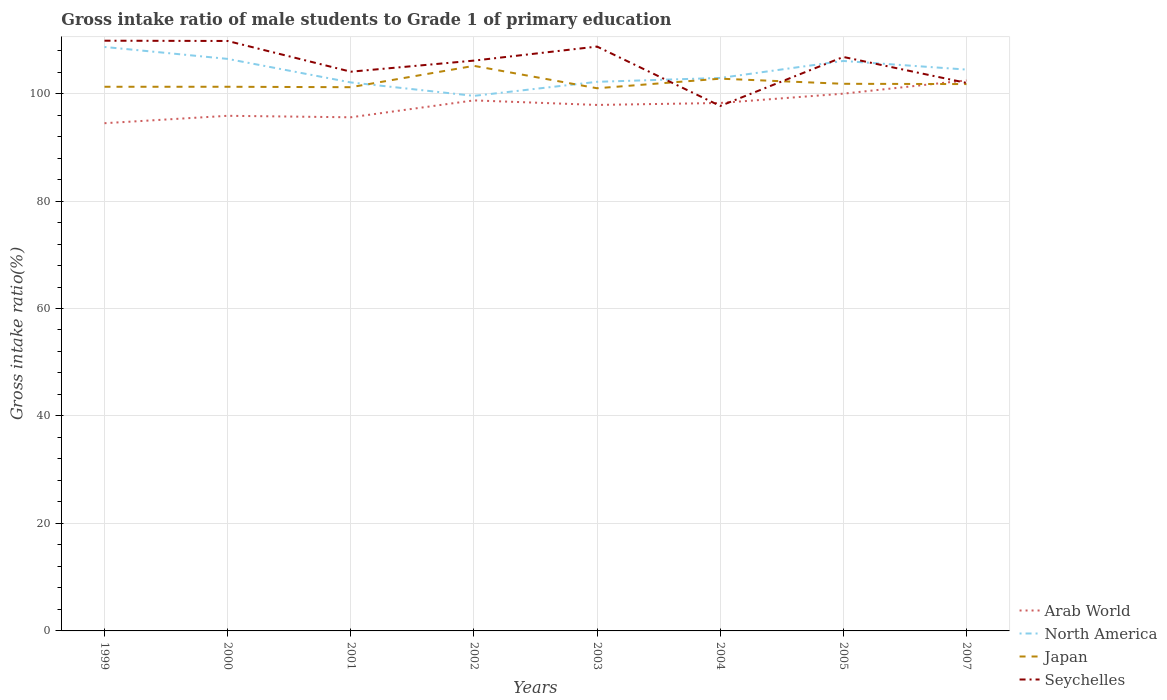How many different coloured lines are there?
Your answer should be very brief. 4. Does the line corresponding to North America intersect with the line corresponding to Seychelles?
Your answer should be very brief. Yes. Across all years, what is the maximum gross intake ratio in Arab World?
Your answer should be very brief. 94.48. What is the total gross intake ratio in Seychelles in the graph?
Keep it short and to the point. 1.04. What is the difference between the highest and the second highest gross intake ratio in Arab World?
Your answer should be very brief. 7.97. What is the difference between the highest and the lowest gross intake ratio in Japan?
Your response must be concise. 2. Is the gross intake ratio in Seychelles strictly greater than the gross intake ratio in Arab World over the years?
Ensure brevity in your answer.  No. How many years are there in the graph?
Give a very brief answer. 8. Are the values on the major ticks of Y-axis written in scientific E-notation?
Make the answer very short. No. Does the graph contain any zero values?
Give a very brief answer. No. Where does the legend appear in the graph?
Give a very brief answer. Bottom right. What is the title of the graph?
Your answer should be compact. Gross intake ratio of male students to Grade 1 of primary education. Does "Guinea" appear as one of the legend labels in the graph?
Ensure brevity in your answer.  No. What is the label or title of the Y-axis?
Provide a succinct answer. Gross intake ratio(%). What is the Gross intake ratio(%) of Arab World in 1999?
Your answer should be compact. 94.48. What is the Gross intake ratio(%) of North America in 1999?
Offer a terse response. 108.67. What is the Gross intake ratio(%) in Japan in 1999?
Keep it short and to the point. 101.26. What is the Gross intake ratio(%) of Seychelles in 1999?
Ensure brevity in your answer.  109.84. What is the Gross intake ratio(%) of Arab World in 2000?
Give a very brief answer. 95.86. What is the Gross intake ratio(%) in North America in 2000?
Your answer should be very brief. 106.45. What is the Gross intake ratio(%) in Japan in 2000?
Ensure brevity in your answer.  101.26. What is the Gross intake ratio(%) of Seychelles in 2000?
Make the answer very short. 109.78. What is the Gross intake ratio(%) of Arab World in 2001?
Provide a short and direct response. 95.58. What is the Gross intake ratio(%) in North America in 2001?
Your response must be concise. 102.07. What is the Gross intake ratio(%) of Japan in 2001?
Ensure brevity in your answer.  101.18. What is the Gross intake ratio(%) of Seychelles in 2001?
Your answer should be compact. 104.07. What is the Gross intake ratio(%) in Arab World in 2002?
Your response must be concise. 98.73. What is the Gross intake ratio(%) of North America in 2002?
Your answer should be compact. 99.57. What is the Gross intake ratio(%) of Japan in 2002?
Give a very brief answer. 105.16. What is the Gross intake ratio(%) in Seychelles in 2002?
Make the answer very short. 106.13. What is the Gross intake ratio(%) of Arab World in 2003?
Keep it short and to the point. 97.88. What is the Gross intake ratio(%) in North America in 2003?
Offer a terse response. 102.18. What is the Gross intake ratio(%) of Japan in 2003?
Ensure brevity in your answer.  100.99. What is the Gross intake ratio(%) in Seychelles in 2003?
Ensure brevity in your answer.  108.74. What is the Gross intake ratio(%) in Arab World in 2004?
Ensure brevity in your answer.  98.24. What is the Gross intake ratio(%) of North America in 2004?
Provide a succinct answer. 102.9. What is the Gross intake ratio(%) in Japan in 2004?
Provide a short and direct response. 102.77. What is the Gross intake ratio(%) in Seychelles in 2004?
Keep it short and to the point. 97.69. What is the Gross intake ratio(%) in Arab World in 2005?
Your answer should be very brief. 99.98. What is the Gross intake ratio(%) in North America in 2005?
Ensure brevity in your answer.  106.07. What is the Gross intake ratio(%) in Japan in 2005?
Provide a succinct answer. 101.82. What is the Gross intake ratio(%) of Seychelles in 2005?
Give a very brief answer. 106.81. What is the Gross intake ratio(%) in Arab World in 2007?
Provide a succinct answer. 102.45. What is the Gross intake ratio(%) of North America in 2007?
Make the answer very short. 104.46. What is the Gross intake ratio(%) of Japan in 2007?
Give a very brief answer. 101.76. What is the Gross intake ratio(%) of Seychelles in 2007?
Keep it short and to the point. 101.98. Across all years, what is the maximum Gross intake ratio(%) in Arab World?
Keep it short and to the point. 102.45. Across all years, what is the maximum Gross intake ratio(%) in North America?
Make the answer very short. 108.67. Across all years, what is the maximum Gross intake ratio(%) in Japan?
Offer a terse response. 105.16. Across all years, what is the maximum Gross intake ratio(%) in Seychelles?
Provide a succinct answer. 109.84. Across all years, what is the minimum Gross intake ratio(%) of Arab World?
Ensure brevity in your answer.  94.48. Across all years, what is the minimum Gross intake ratio(%) of North America?
Your response must be concise. 99.57. Across all years, what is the minimum Gross intake ratio(%) of Japan?
Your response must be concise. 100.99. Across all years, what is the minimum Gross intake ratio(%) in Seychelles?
Your answer should be compact. 97.69. What is the total Gross intake ratio(%) in Arab World in the graph?
Ensure brevity in your answer.  783.21. What is the total Gross intake ratio(%) of North America in the graph?
Give a very brief answer. 832.38. What is the total Gross intake ratio(%) of Japan in the graph?
Make the answer very short. 816.21. What is the total Gross intake ratio(%) in Seychelles in the graph?
Offer a very short reply. 845.05. What is the difference between the Gross intake ratio(%) of Arab World in 1999 and that in 2000?
Keep it short and to the point. -1.38. What is the difference between the Gross intake ratio(%) in North America in 1999 and that in 2000?
Make the answer very short. 2.22. What is the difference between the Gross intake ratio(%) in Japan in 1999 and that in 2000?
Ensure brevity in your answer.  0. What is the difference between the Gross intake ratio(%) of Seychelles in 1999 and that in 2000?
Make the answer very short. 0.05. What is the difference between the Gross intake ratio(%) in North America in 1999 and that in 2001?
Make the answer very short. 6.6. What is the difference between the Gross intake ratio(%) in Japan in 1999 and that in 2001?
Your response must be concise. 0.08. What is the difference between the Gross intake ratio(%) of Seychelles in 1999 and that in 2001?
Keep it short and to the point. 5.77. What is the difference between the Gross intake ratio(%) of Arab World in 1999 and that in 2002?
Make the answer very short. -4.25. What is the difference between the Gross intake ratio(%) in North America in 1999 and that in 2002?
Provide a short and direct response. 9.1. What is the difference between the Gross intake ratio(%) of Japan in 1999 and that in 2002?
Your answer should be very brief. -3.89. What is the difference between the Gross intake ratio(%) of Seychelles in 1999 and that in 2002?
Provide a succinct answer. 3.71. What is the difference between the Gross intake ratio(%) of North America in 1999 and that in 2003?
Your answer should be very brief. 6.49. What is the difference between the Gross intake ratio(%) of Japan in 1999 and that in 2003?
Your answer should be very brief. 0.28. What is the difference between the Gross intake ratio(%) of Seychelles in 1999 and that in 2003?
Make the answer very short. 1.09. What is the difference between the Gross intake ratio(%) of Arab World in 1999 and that in 2004?
Keep it short and to the point. -3.76. What is the difference between the Gross intake ratio(%) of North America in 1999 and that in 2004?
Offer a very short reply. 5.77. What is the difference between the Gross intake ratio(%) of Japan in 1999 and that in 2004?
Offer a very short reply. -1.5. What is the difference between the Gross intake ratio(%) in Seychelles in 1999 and that in 2004?
Your answer should be compact. 12.14. What is the difference between the Gross intake ratio(%) of Arab World in 1999 and that in 2005?
Ensure brevity in your answer.  -5.5. What is the difference between the Gross intake ratio(%) in North America in 1999 and that in 2005?
Your answer should be compact. 2.61. What is the difference between the Gross intake ratio(%) of Japan in 1999 and that in 2005?
Offer a terse response. -0.55. What is the difference between the Gross intake ratio(%) of Seychelles in 1999 and that in 2005?
Give a very brief answer. 3.02. What is the difference between the Gross intake ratio(%) of Arab World in 1999 and that in 2007?
Offer a terse response. -7.97. What is the difference between the Gross intake ratio(%) of North America in 1999 and that in 2007?
Offer a very short reply. 4.21. What is the difference between the Gross intake ratio(%) in Japan in 1999 and that in 2007?
Offer a terse response. -0.5. What is the difference between the Gross intake ratio(%) in Seychelles in 1999 and that in 2007?
Give a very brief answer. 7.85. What is the difference between the Gross intake ratio(%) of Arab World in 2000 and that in 2001?
Offer a terse response. 0.28. What is the difference between the Gross intake ratio(%) in North America in 2000 and that in 2001?
Provide a succinct answer. 4.38. What is the difference between the Gross intake ratio(%) in Japan in 2000 and that in 2001?
Keep it short and to the point. 0.08. What is the difference between the Gross intake ratio(%) of Seychelles in 2000 and that in 2001?
Keep it short and to the point. 5.72. What is the difference between the Gross intake ratio(%) of Arab World in 2000 and that in 2002?
Your answer should be compact. -2.87. What is the difference between the Gross intake ratio(%) in North America in 2000 and that in 2002?
Your answer should be very brief. 6.88. What is the difference between the Gross intake ratio(%) of Japan in 2000 and that in 2002?
Keep it short and to the point. -3.89. What is the difference between the Gross intake ratio(%) of Seychelles in 2000 and that in 2002?
Ensure brevity in your answer.  3.65. What is the difference between the Gross intake ratio(%) in Arab World in 2000 and that in 2003?
Ensure brevity in your answer.  -2.02. What is the difference between the Gross intake ratio(%) of North America in 2000 and that in 2003?
Provide a short and direct response. 4.27. What is the difference between the Gross intake ratio(%) in Japan in 2000 and that in 2003?
Your answer should be compact. 0.28. What is the difference between the Gross intake ratio(%) in Seychelles in 2000 and that in 2003?
Provide a succinct answer. 1.04. What is the difference between the Gross intake ratio(%) in Arab World in 2000 and that in 2004?
Keep it short and to the point. -2.38. What is the difference between the Gross intake ratio(%) in North America in 2000 and that in 2004?
Provide a succinct answer. 3.55. What is the difference between the Gross intake ratio(%) in Japan in 2000 and that in 2004?
Provide a short and direct response. -1.5. What is the difference between the Gross intake ratio(%) in Seychelles in 2000 and that in 2004?
Ensure brevity in your answer.  12.09. What is the difference between the Gross intake ratio(%) in Arab World in 2000 and that in 2005?
Offer a very short reply. -4.12. What is the difference between the Gross intake ratio(%) in North America in 2000 and that in 2005?
Offer a very short reply. 0.38. What is the difference between the Gross intake ratio(%) in Japan in 2000 and that in 2005?
Offer a very short reply. -0.55. What is the difference between the Gross intake ratio(%) in Seychelles in 2000 and that in 2005?
Provide a succinct answer. 2.97. What is the difference between the Gross intake ratio(%) in Arab World in 2000 and that in 2007?
Give a very brief answer. -6.59. What is the difference between the Gross intake ratio(%) of North America in 2000 and that in 2007?
Keep it short and to the point. 1.99. What is the difference between the Gross intake ratio(%) in Japan in 2000 and that in 2007?
Provide a succinct answer. -0.5. What is the difference between the Gross intake ratio(%) of Seychelles in 2000 and that in 2007?
Give a very brief answer. 7.8. What is the difference between the Gross intake ratio(%) in Arab World in 2001 and that in 2002?
Offer a terse response. -3.15. What is the difference between the Gross intake ratio(%) in North America in 2001 and that in 2002?
Offer a very short reply. 2.5. What is the difference between the Gross intake ratio(%) in Japan in 2001 and that in 2002?
Offer a terse response. -3.97. What is the difference between the Gross intake ratio(%) in Seychelles in 2001 and that in 2002?
Your answer should be compact. -2.06. What is the difference between the Gross intake ratio(%) of North America in 2001 and that in 2003?
Provide a succinct answer. -0.11. What is the difference between the Gross intake ratio(%) in Japan in 2001 and that in 2003?
Ensure brevity in your answer.  0.2. What is the difference between the Gross intake ratio(%) of Seychelles in 2001 and that in 2003?
Make the answer very short. -4.68. What is the difference between the Gross intake ratio(%) of Arab World in 2001 and that in 2004?
Your answer should be very brief. -2.66. What is the difference between the Gross intake ratio(%) in North America in 2001 and that in 2004?
Make the answer very short. -0.83. What is the difference between the Gross intake ratio(%) in Japan in 2001 and that in 2004?
Provide a short and direct response. -1.58. What is the difference between the Gross intake ratio(%) of Seychelles in 2001 and that in 2004?
Your answer should be very brief. 6.38. What is the difference between the Gross intake ratio(%) in Arab World in 2001 and that in 2005?
Keep it short and to the point. -4.4. What is the difference between the Gross intake ratio(%) of North America in 2001 and that in 2005?
Ensure brevity in your answer.  -3.99. What is the difference between the Gross intake ratio(%) in Japan in 2001 and that in 2005?
Offer a terse response. -0.63. What is the difference between the Gross intake ratio(%) of Seychelles in 2001 and that in 2005?
Give a very brief answer. -2.74. What is the difference between the Gross intake ratio(%) in Arab World in 2001 and that in 2007?
Your answer should be very brief. -6.87. What is the difference between the Gross intake ratio(%) in North America in 2001 and that in 2007?
Keep it short and to the point. -2.39. What is the difference between the Gross intake ratio(%) of Japan in 2001 and that in 2007?
Provide a short and direct response. -0.58. What is the difference between the Gross intake ratio(%) of Seychelles in 2001 and that in 2007?
Provide a succinct answer. 2.09. What is the difference between the Gross intake ratio(%) in Arab World in 2002 and that in 2003?
Make the answer very short. 0.84. What is the difference between the Gross intake ratio(%) in North America in 2002 and that in 2003?
Your response must be concise. -2.61. What is the difference between the Gross intake ratio(%) in Japan in 2002 and that in 2003?
Your answer should be very brief. 4.17. What is the difference between the Gross intake ratio(%) in Seychelles in 2002 and that in 2003?
Provide a succinct answer. -2.61. What is the difference between the Gross intake ratio(%) of Arab World in 2002 and that in 2004?
Provide a succinct answer. 0.48. What is the difference between the Gross intake ratio(%) of North America in 2002 and that in 2004?
Ensure brevity in your answer.  -3.33. What is the difference between the Gross intake ratio(%) of Japan in 2002 and that in 2004?
Your answer should be very brief. 2.39. What is the difference between the Gross intake ratio(%) of Seychelles in 2002 and that in 2004?
Offer a terse response. 8.44. What is the difference between the Gross intake ratio(%) of Arab World in 2002 and that in 2005?
Your answer should be compact. -1.25. What is the difference between the Gross intake ratio(%) of North America in 2002 and that in 2005?
Provide a succinct answer. -6.49. What is the difference between the Gross intake ratio(%) in Japan in 2002 and that in 2005?
Your response must be concise. 3.34. What is the difference between the Gross intake ratio(%) of Seychelles in 2002 and that in 2005?
Your answer should be compact. -0.68. What is the difference between the Gross intake ratio(%) in Arab World in 2002 and that in 2007?
Provide a succinct answer. -3.72. What is the difference between the Gross intake ratio(%) of North America in 2002 and that in 2007?
Ensure brevity in your answer.  -4.89. What is the difference between the Gross intake ratio(%) in Japan in 2002 and that in 2007?
Your answer should be very brief. 3.39. What is the difference between the Gross intake ratio(%) of Seychelles in 2002 and that in 2007?
Keep it short and to the point. 4.15. What is the difference between the Gross intake ratio(%) of Arab World in 2003 and that in 2004?
Provide a succinct answer. -0.36. What is the difference between the Gross intake ratio(%) of North America in 2003 and that in 2004?
Your answer should be very brief. -0.72. What is the difference between the Gross intake ratio(%) in Japan in 2003 and that in 2004?
Your answer should be compact. -1.78. What is the difference between the Gross intake ratio(%) of Seychelles in 2003 and that in 2004?
Offer a terse response. 11.05. What is the difference between the Gross intake ratio(%) in Arab World in 2003 and that in 2005?
Offer a very short reply. -2.1. What is the difference between the Gross intake ratio(%) in North America in 2003 and that in 2005?
Give a very brief answer. -3.88. What is the difference between the Gross intake ratio(%) of Japan in 2003 and that in 2005?
Your response must be concise. -0.83. What is the difference between the Gross intake ratio(%) of Seychelles in 2003 and that in 2005?
Your answer should be very brief. 1.93. What is the difference between the Gross intake ratio(%) in Arab World in 2003 and that in 2007?
Your answer should be compact. -4.57. What is the difference between the Gross intake ratio(%) in North America in 2003 and that in 2007?
Offer a terse response. -2.28. What is the difference between the Gross intake ratio(%) in Japan in 2003 and that in 2007?
Offer a terse response. -0.78. What is the difference between the Gross intake ratio(%) in Seychelles in 2003 and that in 2007?
Give a very brief answer. 6.76. What is the difference between the Gross intake ratio(%) of Arab World in 2004 and that in 2005?
Offer a very short reply. -1.73. What is the difference between the Gross intake ratio(%) in North America in 2004 and that in 2005?
Offer a very short reply. -3.16. What is the difference between the Gross intake ratio(%) of Japan in 2004 and that in 2005?
Offer a terse response. 0.95. What is the difference between the Gross intake ratio(%) of Seychelles in 2004 and that in 2005?
Keep it short and to the point. -9.12. What is the difference between the Gross intake ratio(%) of Arab World in 2004 and that in 2007?
Make the answer very short. -4.2. What is the difference between the Gross intake ratio(%) of North America in 2004 and that in 2007?
Provide a short and direct response. -1.56. What is the difference between the Gross intake ratio(%) of Japan in 2004 and that in 2007?
Offer a terse response. 1. What is the difference between the Gross intake ratio(%) in Seychelles in 2004 and that in 2007?
Offer a very short reply. -4.29. What is the difference between the Gross intake ratio(%) in Arab World in 2005 and that in 2007?
Your response must be concise. -2.47. What is the difference between the Gross intake ratio(%) in North America in 2005 and that in 2007?
Offer a terse response. 1.6. What is the difference between the Gross intake ratio(%) of Japan in 2005 and that in 2007?
Offer a very short reply. 0.05. What is the difference between the Gross intake ratio(%) in Seychelles in 2005 and that in 2007?
Keep it short and to the point. 4.83. What is the difference between the Gross intake ratio(%) of Arab World in 1999 and the Gross intake ratio(%) of North America in 2000?
Offer a very short reply. -11.97. What is the difference between the Gross intake ratio(%) of Arab World in 1999 and the Gross intake ratio(%) of Japan in 2000?
Make the answer very short. -6.78. What is the difference between the Gross intake ratio(%) in Arab World in 1999 and the Gross intake ratio(%) in Seychelles in 2000?
Your answer should be compact. -15.3. What is the difference between the Gross intake ratio(%) in North America in 1999 and the Gross intake ratio(%) in Japan in 2000?
Ensure brevity in your answer.  7.41. What is the difference between the Gross intake ratio(%) in North America in 1999 and the Gross intake ratio(%) in Seychelles in 2000?
Provide a short and direct response. -1.11. What is the difference between the Gross intake ratio(%) of Japan in 1999 and the Gross intake ratio(%) of Seychelles in 2000?
Ensure brevity in your answer.  -8.52. What is the difference between the Gross intake ratio(%) of Arab World in 1999 and the Gross intake ratio(%) of North America in 2001?
Ensure brevity in your answer.  -7.59. What is the difference between the Gross intake ratio(%) of Arab World in 1999 and the Gross intake ratio(%) of Japan in 2001?
Offer a terse response. -6.7. What is the difference between the Gross intake ratio(%) in Arab World in 1999 and the Gross intake ratio(%) in Seychelles in 2001?
Your answer should be very brief. -9.59. What is the difference between the Gross intake ratio(%) of North America in 1999 and the Gross intake ratio(%) of Japan in 2001?
Provide a succinct answer. 7.49. What is the difference between the Gross intake ratio(%) in North America in 1999 and the Gross intake ratio(%) in Seychelles in 2001?
Keep it short and to the point. 4.6. What is the difference between the Gross intake ratio(%) in Japan in 1999 and the Gross intake ratio(%) in Seychelles in 2001?
Your response must be concise. -2.8. What is the difference between the Gross intake ratio(%) of Arab World in 1999 and the Gross intake ratio(%) of North America in 2002?
Your response must be concise. -5.09. What is the difference between the Gross intake ratio(%) in Arab World in 1999 and the Gross intake ratio(%) in Japan in 2002?
Offer a very short reply. -10.67. What is the difference between the Gross intake ratio(%) of Arab World in 1999 and the Gross intake ratio(%) of Seychelles in 2002?
Offer a very short reply. -11.65. What is the difference between the Gross intake ratio(%) in North America in 1999 and the Gross intake ratio(%) in Japan in 2002?
Offer a terse response. 3.52. What is the difference between the Gross intake ratio(%) in North America in 1999 and the Gross intake ratio(%) in Seychelles in 2002?
Ensure brevity in your answer.  2.54. What is the difference between the Gross intake ratio(%) in Japan in 1999 and the Gross intake ratio(%) in Seychelles in 2002?
Provide a succinct answer. -4.87. What is the difference between the Gross intake ratio(%) in Arab World in 1999 and the Gross intake ratio(%) in North America in 2003?
Your response must be concise. -7.7. What is the difference between the Gross intake ratio(%) of Arab World in 1999 and the Gross intake ratio(%) of Japan in 2003?
Offer a very short reply. -6.5. What is the difference between the Gross intake ratio(%) in Arab World in 1999 and the Gross intake ratio(%) in Seychelles in 2003?
Ensure brevity in your answer.  -14.26. What is the difference between the Gross intake ratio(%) of North America in 1999 and the Gross intake ratio(%) of Japan in 2003?
Keep it short and to the point. 7.68. What is the difference between the Gross intake ratio(%) of North America in 1999 and the Gross intake ratio(%) of Seychelles in 2003?
Offer a very short reply. -0.07. What is the difference between the Gross intake ratio(%) of Japan in 1999 and the Gross intake ratio(%) of Seychelles in 2003?
Provide a succinct answer. -7.48. What is the difference between the Gross intake ratio(%) of Arab World in 1999 and the Gross intake ratio(%) of North America in 2004?
Offer a very short reply. -8.42. What is the difference between the Gross intake ratio(%) in Arab World in 1999 and the Gross intake ratio(%) in Japan in 2004?
Make the answer very short. -8.29. What is the difference between the Gross intake ratio(%) in Arab World in 1999 and the Gross intake ratio(%) in Seychelles in 2004?
Provide a short and direct response. -3.21. What is the difference between the Gross intake ratio(%) of North America in 1999 and the Gross intake ratio(%) of Japan in 2004?
Offer a very short reply. 5.9. What is the difference between the Gross intake ratio(%) of North America in 1999 and the Gross intake ratio(%) of Seychelles in 2004?
Your answer should be very brief. 10.98. What is the difference between the Gross intake ratio(%) of Japan in 1999 and the Gross intake ratio(%) of Seychelles in 2004?
Offer a very short reply. 3.57. What is the difference between the Gross intake ratio(%) of Arab World in 1999 and the Gross intake ratio(%) of North America in 2005?
Provide a short and direct response. -11.58. What is the difference between the Gross intake ratio(%) in Arab World in 1999 and the Gross intake ratio(%) in Japan in 2005?
Keep it short and to the point. -7.33. What is the difference between the Gross intake ratio(%) of Arab World in 1999 and the Gross intake ratio(%) of Seychelles in 2005?
Make the answer very short. -12.33. What is the difference between the Gross intake ratio(%) in North America in 1999 and the Gross intake ratio(%) in Japan in 2005?
Keep it short and to the point. 6.86. What is the difference between the Gross intake ratio(%) of North America in 1999 and the Gross intake ratio(%) of Seychelles in 2005?
Make the answer very short. 1.86. What is the difference between the Gross intake ratio(%) in Japan in 1999 and the Gross intake ratio(%) in Seychelles in 2005?
Your response must be concise. -5.55. What is the difference between the Gross intake ratio(%) of Arab World in 1999 and the Gross intake ratio(%) of North America in 2007?
Ensure brevity in your answer.  -9.98. What is the difference between the Gross intake ratio(%) in Arab World in 1999 and the Gross intake ratio(%) in Japan in 2007?
Offer a very short reply. -7.28. What is the difference between the Gross intake ratio(%) in Arab World in 1999 and the Gross intake ratio(%) in Seychelles in 2007?
Your answer should be very brief. -7.5. What is the difference between the Gross intake ratio(%) of North America in 1999 and the Gross intake ratio(%) of Japan in 2007?
Provide a succinct answer. 6.91. What is the difference between the Gross intake ratio(%) of North America in 1999 and the Gross intake ratio(%) of Seychelles in 2007?
Make the answer very short. 6.69. What is the difference between the Gross intake ratio(%) in Japan in 1999 and the Gross intake ratio(%) in Seychelles in 2007?
Provide a succinct answer. -0.72. What is the difference between the Gross intake ratio(%) in Arab World in 2000 and the Gross intake ratio(%) in North America in 2001?
Make the answer very short. -6.21. What is the difference between the Gross intake ratio(%) in Arab World in 2000 and the Gross intake ratio(%) in Japan in 2001?
Make the answer very short. -5.32. What is the difference between the Gross intake ratio(%) of Arab World in 2000 and the Gross intake ratio(%) of Seychelles in 2001?
Offer a terse response. -8.21. What is the difference between the Gross intake ratio(%) of North America in 2000 and the Gross intake ratio(%) of Japan in 2001?
Make the answer very short. 5.27. What is the difference between the Gross intake ratio(%) of North America in 2000 and the Gross intake ratio(%) of Seychelles in 2001?
Make the answer very short. 2.38. What is the difference between the Gross intake ratio(%) of Japan in 2000 and the Gross intake ratio(%) of Seychelles in 2001?
Your answer should be very brief. -2.8. What is the difference between the Gross intake ratio(%) of Arab World in 2000 and the Gross intake ratio(%) of North America in 2002?
Your answer should be compact. -3.71. What is the difference between the Gross intake ratio(%) of Arab World in 2000 and the Gross intake ratio(%) of Japan in 2002?
Make the answer very short. -9.3. What is the difference between the Gross intake ratio(%) in Arab World in 2000 and the Gross intake ratio(%) in Seychelles in 2002?
Your answer should be compact. -10.27. What is the difference between the Gross intake ratio(%) of North America in 2000 and the Gross intake ratio(%) of Japan in 2002?
Provide a succinct answer. 1.29. What is the difference between the Gross intake ratio(%) in North America in 2000 and the Gross intake ratio(%) in Seychelles in 2002?
Your response must be concise. 0.32. What is the difference between the Gross intake ratio(%) of Japan in 2000 and the Gross intake ratio(%) of Seychelles in 2002?
Your answer should be compact. -4.87. What is the difference between the Gross intake ratio(%) in Arab World in 2000 and the Gross intake ratio(%) in North America in 2003?
Give a very brief answer. -6.32. What is the difference between the Gross intake ratio(%) of Arab World in 2000 and the Gross intake ratio(%) of Japan in 2003?
Give a very brief answer. -5.13. What is the difference between the Gross intake ratio(%) in Arab World in 2000 and the Gross intake ratio(%) in Seychelles in 2003?
Your answer should be very brief. -12.88. What is the difference between the Gross intake ratio(%) of North America in 2000 and the Gross intake ratio(%) of Japan in 2003?
Your answer should be compact. 5.46. What is the difference between the Gross intake ratio(%) of North America in 2000 and the Gross intake ratio(%) of Seychelles in 2003?
Keep it short and to the point. -2.29. What is the difference between the Gross intake ratio(%) in Japan in 2000 and the Gross intake ratio(%) in Seychelles in 2003?
Ensure brevity in your answer.  -7.48. What is the difference between the Gross intake ratio(%) in Arab World in 2000 and the Gross intake ratio(%) in North America in 2004?
Your response must be concise. -7.04. What is the difference between the Gross intake ratio(%) in Arab World in 2000 and the Gross intake ratio(%) in Japan in 2004?
Your response must be concise. -6.91. What is the difference between the Gross intake ratio(%) in Arab World in 2000 and the Gross intake ratio(%) in Seychelles in 2004?
Your answer should be very brief. -1.83. What is the difference between the Gross intake ratio(%) in North America in 2000 and the Gross intake ratio(%) in Japan in 2004?
Your answer should be compact. 3.68. What is the difference between the Gross intake ratio(%) in North America in 2000 and the Gross intake ratio(%) in Seychelles in 2004?
Make the answer very short. 8.76. What is the difference between the Gross intake ratio(%) in Japan in 2000 and the Gross intake ratio(%) in Seychelles in 2004?
Give a very brief answer. 3.57. What is the difference between the Gross intake ratio(%) of Arab World in 2000 and the Gross intake ratio(%) of North America in 2005?
Provide a succinct answer. -10.2. What is the difference between the Gross intake ratio(%) in Arab World in 2000 and the Gross intake ratio(%) in Japan in 2005?
Provide a short and direct response. -5.95. What is the difference between the Gross intake ratio(%) of Arab World in 2000 and the Gross intake ratio(%) of Seychelles in 2005?
Give a very brief answer. -10.95. What is the difference between the Gross intake ratio(%) in North America in 2000 and the Gross intake ratio(%) in Japan in 2005?
Your answer should be very brief. 4.63. What is the difference between the Gross intake ratio(%) in North America in 2000 and the Gross intake ratio(%) in Seychelles in 2005?
Ensure brevity in your answer.  -0.36. What is the difference between the Gross intake ratio(%) in Japan in 2000 and the Gross intake ratio(%) in Seychelles in 2005?
Your answer should be very brief. -5.55. What is the difference between the Gross intake ratio(%) in Arab World in 2000 and the Gross intake ratio(%) in North America in 2007?
Ensure brevity in your answer.  -8.6. What is the difference between the Gross intake ratio(%) in Arab World in 2000 and the Gross intake ratio(%) in Japan in 2007?
Make the answer very short. -5.9. What is the difference between the Gross intake ratio(%) in Arab World in 2000 and the Gross intake ratio(%) in Seychelles in 2007?
Provide a short and direct response. -6.12. What is the difference between the Gross intake ratio(%) of North America in 2000 and the Gross intake ratio(%) of Japan in 2007?
Your answer should be very brief. 4.68. What is the difference between the Gross intake ratio(%) of North America in 2000 and the Gross intake ratio(%) of Seychelles in 2007?
Ensure brevity in your answer.  4.47. What is the difference between the Gross intake ratio(%) of Japan in 2000 and the Gross intake ratio(%) of Seychelles in 2007?
Provide a short and direct response. -0.72. What is the difference between the Gross intake ratio(%) of Arab World in 2001 and the Gross intake ratio(%) of North America in 2002?
Your response must be concise. -3.99. What is the difference between the Gross intake ratio(%) in Arab World in 2001 and the Gross intake ratio(%) in Japan in 2002?
Provide a succinct answer. -9.57. What is the difference between the Gross intake ratio(%) of Arab World in 2001 and the Gross intake ratio(%) of Seychelles in 2002?
Give a very brief answer. -10.55. What is the difference between the Gross intake ratio(%) of North America in 2001 and the Gross intake ratio(%) of Japan in 2002?
Provide a succinct answer. -3.08. What is the difference between the Gross intake ratio(%) in North America in 2001 and the Gross intake ratio(%) in Seychelles in 2002?
Provide a short and direct response. -4.06. What is the difference between the Gross intake ratio(%) in Japan in 2001 and the Gross intake ratio(%) in Seychelles in 2002?
Ensure brevity in your answer.  -4.95. What is the difference between the Gross intake ratio(%) of Arab World in 2001 and the Gross intake ratio(%) of North America in 2003?
Your answer should be compact. -6.6. What is the difference between the Gross intake ratio(%) in Arab World in 2001 and the Gross intake ratio(%) in Japan in 2003?
Give a very brief answer. -5.4. What is the difference between the Gross intake ratio(%) of Arab World in 2001 and the Gross intake ratio(%) of Seychelles in 2003?
Provide a succinct answer. -13.16. What is the difference between the Gross intake ratio(%) of North America in 2001 and the Gross intake ratio(%) of Japan in 2003?
Offer a terse response. 1.08. What is the difference between the Gross intake ratio(%) of North America in 2001 and the Gross intake ratio(%) of Seychelles in 2003?
Make the answer very short. -6.67. What is the difference between the Gross intake ratio(%) of Japan in 2001 and the Gross intake ratio(%) of Seychelles in 2003?
Offer a terse response. -7.56. What is the difference between the Gross intake ratio(%) of Arab World in 2001 and the Gross intake ratio(%) of North America in 2004?
Offer a terse response. -7.32. What is the difference between the Gross intake ratio(%) in Arab World in 2001 and the Gross intake ratio(%) in Japan in 2004?
Your response must be concise. -7.19. What is the difference between the Gross intake ratio(%) of Arab World in 2001 and the Gross intake ratio(%) of Seychelles in 2004?
Give a very brief answer. -2.11. What is the difference between the Gross intake ratio(%) in North America in 2001 and the Gross intake ratio(%) in Japan in 2004?
Offer a very short reply. -0.7. What is the difference between the Gross intake ratio(%) of North America in 2001 and the Gross intake ratio(%) of Seychelles in 2004?
Provide a short and direct response. 4.38. What is the difference between the Gross intake ratio(%) in Japan in 2001 and the Gross intake ratio(%) in Seychelles in 2004?
Keep it short and to the point. 3.49. What is the difference between the Gross intake ratio(%) in Arab World in 2001 and the Gross intake ratio(%) in North America in 2005?
Make the answer very short. -10.48. What is the difference between the Gross intake ratio(%) of Arab World in 2001 and the Gross intake ratio(%) of Japan in 2005?
Give a very brief answer. -6.23. What is the difference between the Gross intake ratio(%) in Arab World in 2001 and the Gross intake ratio(%) in Seychelles in 2005?
Provide a succinct answer. -11.23. What is the difference between the Gross intake ratio(%) of North America in 2001 and the Gross intake ratio(%) of Japan in 2005?
Offer a very short reply. 0.26. What is the difference between the Gross intake ratio(%) in North America in 2001 and the Gross intake ratio(%) in Seychelles in 2005?
Make the answer very short. -4.74. What is the difference between the Gross intake ratio(%) of Japan in 2001 and the Gross intake ratio(%) of Seychelles in 2005?
Keep it short and to the point. -5.63. What is the difference between the Gross intake ratio(%) in Arab World in 2001 and the Gross intake ratio(%) in North America in 2007?
Your answer should be compact. -8.88. What is the difference between the Gross intake ratio(%) of Arab World in 2001 and the Gross intake ratio(%) of Japan in 2007?
Provide a succinct answer. -6.18. What is the difference between the Gross intake ratio(%) of Arab World in 2001 and the Gross intake ratio(%) of Seychelles in 2007?
Keep it short and to the point. -6.4. What is the difference between the Gross intake ratio(%) of North America in 2001 and the Gross intake ratio(%) of Japan in 2007?
Keep it short and to the point. 0.31. What is the difference between the Gross intake ratio(%) of North America in 2001 and the Gross intake ratio(%) of Seychelles in 2007?
Keep it short and to the point. 0.09. What is the difference between the Gross intake ratio(%) in Japan in 2001 and the Gross intake ratio(%) in Seychelles in 2007?
Your answer should be compact. -0.8. What is the difference between the Gross intake ratio(%) of Arab World in 2002 and the Gross intake ratio(%) of North America in 2003?
Keep it short and to the point. -3.46. What is the difference between the Gross intake ratio(%) in Arab World in 2002 and the Gross intake ratio(%) in Japan in 2003?
Keep it short and to the point. -2.26. What is the difference between the Gross intake ratio(%) of Arab World in 2002 and the Gross intake ratio(%) of Seychelles in 2003?
Make the answer very short. -10.02. What is the difference between the Gross intake ratio(%) in North America in 2002 and the Gross intake ratio(%) in Japan in 2003?
Provide a short and direct response. -1.42. What is the difference between the Gross intake ratio(%) in North America in 2002 and the Gross intake ratio(%) in Seychelles in 2003?
Ensure brevity in your answer.  -9.17. What is the difference between the Gross intake ratio(%) of Japan in 2002 and the Gross intake ratio(%) of Seychelles in 2003?
Ensure brevity in your answer.  -3.59. What is the difference between the Gross intake ratio(%) in Arab World in 2002 and the Gross intake ratio(%) in North America in 2004?
Your response must be concise. -4.18. What is the difference between the Gross intake ratio(%) in Arab World in 2002 and the Gross intake ratio(%) in Japan in 2004?
Ensure brevity in your answer.  -4.04. What is the difference between the Gross intake ratio(%) of Arab World in 2002 and the Gross intake ratio(%) of Seychelles in 2004?
Give a very brief answer. 1.04. What is the difference between the Gross intake ratio(%) of North America in 2002 and the Gross intake ratio(%) of Japan in 2004?
Offer a terse response. -3.2. What is the difference between the Gross intake ratio(%) of North America in 2002 and the Gross intake ratio(%) of Seychelles in 2004?
Ensure brevity in your answer.  1.88. What is the difference between the Gross intake ratio(%) in Japan in 2002 and the Gross intake ratio(%) in Seychelles in 2004?
Provide a short and direct response. 7.46. What is the difference between the Gross intake ratio(%) of Arab World in 2002 and the Gross intake ratio(%) of North America in 2005?
Give a very brief answer. -7.34. What is the difference between the Gross intake ratio(%) in Arab World in 2002 and the Gross intake ratio(%) in Japan in 2005?
Make the answer very short. -3.09. What is the difference between the Gross intake ratio(%) in Arab World in 2002 and the Gross intake ratio(%) in Seychelles in 2005?
Provide a succinct answer. -8.08. What is the difference between the Gross intake ratio(%) in North America in 2002 and the Gross intake ratio(%) in Japan in 2005?
Offer a very short reply. -2.24. What is the difference between the Gross intake ratio(%) in North America in 2002 and the Gross intake ratio(%) in Seychelles in 2005?
Provide a succinct answer. -7.24. What is the difference between the Gross intake ratio(%) in Japan in 2002 and the Gross intake ratio(%) in Seychelles in 2005?
Give a very brief answer. -1.66. What is the difference between the Gross intake ratio(%) in Arab World in 2002 and the Gross intake ratio(%) in North America in 2007?
Ensure brevity in your answer.  -5.73. What is the difference between the Gross intake ratio(%) of Arab World in 2002 and the Gross intake ratio(%) of Japan in 2007?
Your answer should be very brief. -3.04. What is the difference between the Gross intake ratio(%) of Arab World in 2002 and the Gross intake ratio(%) of Seychelles in 2007?
Give a very brief answer. -3.26. What is the difference between the Gross intake ratio(%) in North America in 2002 and the Gross intake ratio(%) in Japan in 2007?
Your answer should be very brief. -2.19. What is the difference between the Gross intake ratio(%) of North America in 2002 and the Gross intake ratio(%) of Seychelles in 2007?
Provide a short and direct response. -2.41. What is the difference between the Gross intake ratio(%) of Japan in 2002 and the Gross intake ratio(%) of Seychelles in 2007?
Provide a succinct answer. 3.17. What is the difference between the Gross intake ratio(%) in Arab World in 2003 and the Gross intake ratio(%) in North America in 2004?
Your answer should be compact. -5.02. What is the difference between the Gross intake ratio(%) in Arab World in 2003 and the Gross intake ratio(%) in Japan in 2004?
Provide a short and direct response. -4.89. What is the difference between the Gross intake ratio(%) in Arab World in 2003 and the Gross intake ratio(%) in Seychelles in 2004?
Provide a succinct answer. 0.19. What is the difference between the Gross intake ratio(%) in North America in 2003 and the Gross intake ratio(%) in Japan in 2004?
Keep it short and to the point. -0.58. What is the difference between the Gross intake ratio(%) of North America in 2003 and the Gross intake ratio(%) of Seychelles in 2004?
Ensure brevity in your answer.  4.49. What is the difference between the Gross intake ratio(%) in Japan in 2003 and the Gross intake ratio(%) in Seychelles in 2004?
Offer a very short reply. 3.3. What is the difference between the Gross intake ratio(%) of Arab World in 2003 and the Gross intake ratio(%) of North America in 2005?
Make the answer very short. -8.18. What is the difference between the Gross intake ratio(%) of Arab World in 2003 and the Gross intake ratio(%) of Japan in 2005?
Your response must be concise. -3.93. What is the difference between the Gross intake ratio(%) in Arab World in 2003 and the Gross intake ratio(%) in Seychelles in 2005?
Make the answer very short. -8.93. What is the difference between the Gross intake ratio(%) of North America in 2003 and the Gross intake ratio(%) of Japan in 2005?
Your response must be concise. 0.37. What is the difference between the Gross intake ratio(%) of North America in 2003 and the Gross intake ratio(%) of Seychelles in 2005?
Your response must be concise. -4.63. What is the difference between the Gross intake ratio(%) of Japan in 2003 and the Gross intake ratio(%) of Seychelles in 2005?
Your answer should be compact. -5.82. What is the difference between the Gross intake ratio(%) of Arab World in 2003 and the Gross intake ratio(%) of North America in 2007?
Your answer should be very brief. -6.58. What is the difference between the Gross intake ratio(%) of Arab World in 2003 and the Gross intake ratio(%) of Japan in 2007?
Your answer should be compact. -3.88. What is the difference between the Gross intake ratio(%) in Arab World in 2003 and the Gross intake ratio(%) in Seychelles in 2007?
Your answer should be very brief. -4.1. What is the difference between the Gross intake ratio(%) in North America in 2003 and the Gross intake ratio(%) in Japan in 2007?
Make the answer very short. 0.42. What is the difference between the Gross intake ratio(%) in North America in 2003 and the Gross intake ratio(%) in Seychelles in 2007?
Provide a succinct answer. 0.2. What is the difference between the Gross intake ratio(%) in Japan in 2003 and the Gross intake ratio(%) in Seychelles in 2007?
Your answer should be compact. -1. What is the difference between the Gross intake ratio(%) in Arab World in 2004 and the Gross intake ratio(%) in North America in 2005?
Provide a succinct answer. -7.82. What is the difference between the Gross intake ratio(%) of Arab World in 2004 and the Gross intake ratio(%) of Japan in 2005?
Provide a succinct answer. -3.57. What is the difference between the Gross intake ratio(%) of Arab World in 2004 and the Gross intake ratio(%) of Seychelles in 2005?
Keep it short and to the point. -8.57. What is the difference between the Gross intake ratio(%) in North America in 2004 and the Gross intake ratio(%) in Japan in 2005?
Your answer should be compact. 1.09. What is the difference between the Gross intake ratio(%) of North America in 2004 and the Gross intake ratio(%) of Seychelles in 2005?
Your response must be concise. -3.91. What is the difference between the Gross intake ratio(%) in Japan in 2004 and the Gross intake ratio(%) in Seychelles in 2005?
Your answer should be very brief. -4.04. What is the difference between the Gross intake ratio(%) in Arab World in 2004 and the Gross intake ratio(%) in North America in 2007?
Your answer should be compact. -6.22. What is the difference between the Gross intake ratio(%) in Arab World in 2004 and the Gross intake ratio(%) in Japan in 2007?
Offer a terse response. -3.52. What is the difference between the Gross intake ratio(%) in Arab World in 2004 and the Gross intake ratio(%) in Seychelles in 2007?
Offer a very short reply. -3.74. What is the difference between the Gross intake ratio(%) of North America in 2004 and the Gross intake ratio(%) of Japan in 2007?
Keep it short and to the point. 1.14. What is the difference between the Gross intake ratio(%) in North America in 2004 and the Gross intake ratio(%) in Seychelles in 2007?
Give a very brief answer. 0.92. What is the difference between the Gross intake ratio(%) in Japan in 2004 and the Gross intake ratio(%) in Seychelles in 2007?
Provide a succinct answer. 0.79. What is the difference between the Gross intake ratio(%) of Arab World in 2005 and the Gross intake ratio(%) of North America in 2007?
Your answer should be compact. -4.48. What is the difference between the Gross intake ratio(%) of Arab World in 2005 and the Gross intake ratio(%) of Japan in 2007?
Provide a short and direct response. -1.79. What is the difference between the Gross intake ratio(%) in Arab World in 2005 and the Gross intake ratio(%) in Seychelles in 2007?
Your answer should be compact. -2. What is the difference between the Gross intake ratio(%) of North America in 2005 and the Gross intake ratio(%) of Japan in 2007?
Your answer should be very brief. 4.3. What is the difference between the Gross intake ratio(%) of North America in 2005 and the Gross intake ratio(%) of Seychelles in 2007?
Provide a short and direct response. 4.08. What is the difference between the Gross intake ratio(%) in Japan in 2005 and the Gross intake ratio(%) in Seychelles in 2007?
Your answer should be very brief. -0.17. What is the average Gross intake ratio(%) of Arab World per year?
Make the answer very short. 97.9. What is the average Gross intake ratio(%) of North America per year?
Offer a terse response. 104.05. What is the average Gross intake ratio(%) in Japan per year?
Provide a succinct answer. 102.03. What is the average Gross intake ratio(%) of Seychelles per year?
Offer a very short reply. 105.63. In the year 1999, what is the difference between the Gross intake ratio(%) in Arab World and Gross intake ratio(%) in North America?
Your response must be concise. -14.19. In the year 1999, what is the difference between the Gross intake ratio(%) in Arab World and Gross intake ratio(%) in Japan?
Your answer should be compact. -6.78. In the year 1999, what is the difference between the Gross intake ratio(%) in Arab World and Gross intake ratio(%) in Seychelles?
Offer a terse response. -15.35. In the year 1999, what is the difference between the Gross intake ratio(%) in North America and Gross intake ratio(%) in Japan?
Offer a terse response. 7.41. In the year 1999, what is the difference between the Gross intake ratio(%) of North America and Gross intake ratio(%) of Seychelles?
Give a very brief answer. -1.16. In the year 1999, what is the difference between the Gross intake ratio(%) in Japan and Gross intake ratio(%) in Seychelles?
Ensure brevity in your answer.  -8.57. In the year 2000, what is the difference between the Gross intake ratio(%) in Arab World and Gross intake ratio(%) in North America?
Provide a short and direct response. -10.59. In the year 2000, what is the difference between the Gross intake ratio(%) in Arab World and Gross intake ratio(%) in Japan?
Your response must be concise. -5.4. In the year 2000, what is the difference between the Gross intake ratio(%) of Arab World and Gross intake ratio(%) of Seychelles?
Provide a short and direct response. -13.92. In the year 2000, what is the difference between the Gross intake ratio(%) of North America and Gross intake ratio(%) of Japan?
Provide a succinct answer. 5.19. In the year 2000, what is the difference between the Gross intake ratio(%) in North America and Gross intake ratio(%) in Seychelles?
Keep it short and to the point. -3.33. In the year 2000, what is the difference between the Gross intake ratio(%) of Japan and Gross intake ratio(%) of Seychelles?
Offer a terse response. -8.52. In the year 2001, what is the difference between the Gross intake ratio(%) of Arab World and Gross intake ratio(%) of North America?
Make the answer very short. -6.49. In the year 2001, what is the difference between the Gross intake ratio(%) of Arab World and Gross intake ratio(%) of Japan?
Offer a very short reply. -5.6. In the year 2001, what is the difference between the Gross intake ratio(%) in Arab World and Gross intake ratio(%) in Seychelles?
Your answer should be compact. -8.49. In the year 2001, what is the difference between the Gross intake ratio(%) of North America and Gross intake ratio(%) of Japan?
Provide a short and direct response. 0.89. In the year 2001, what is the difference between the Gross intake ratio(%) in North America and Gross intake ratio(%) in Seychelles?
Ensure brevity in your answer.  -2. In the year 2001, what is the difference between the Gross intake ratio(%) of Japan and Gross intake ratio(%) of Seychelles?
Give a very brief answer. -2.88. In the year 2002, what is the difference between the Gross intake ratio(%) in Arab World and Gross intake ratio(%) in North America?
Offer a very short reply. -0.84. In the year 2002, what is the difference between the Gross intake ratio(%) in Arab World and Gross intake ratio(%) in Japan?
Offer a very short reply. -6.43. In the year 2002, what is the difference between the Gross intake ratio(%) in Arab World and Gross intake ratio(%) in Seychelles?
Provide a short and direct response. -7.4. In the year 2002, what is the difference between the Gross intake ratio(%) of North America and Gross intake ratio(%) of Japan?
Ensure brevity in your answer.  -5.58. In the year 2002, what is the difference between the Gross intake ratio(%) of North America and Gross intake ratio(%) of Seychelles?
Provide a succinct answer. -6.56. In the year 2002, what is the difference between the Gross intake ratio(%) in Japan and Gross intake ratio(%) in Seychelles?
Offer a terse response. -0.97. In the year 2003, what is the difference between the Gross intake ratio(%) in Arab World and Gross intake ratio(%) in North America?
Offer a very short reply. -4.3. In the year 2003, what is the difference between the Gross intake ratio(%) in Arab World and Gross intake ratio(%) in Japan?
Provide a succinct answer. -3.1. In the year 2003, what is the difference between the Gross intake ratio(%) in Arab World and Gross intake ratio(%) in Seychelles?
Provide a succinct answer. -10.86. In the year 2003, what is the difference between the Gross intake ratio(%) of North America and Gross intake ratio(%) of Japan?
Your answer should be compact. 1.2. In the year 2003, what is the difference between the Gross intake ratio(%) of North America and Gross intake ratio(%) of Seychelles?
Your response must be concise. -6.56. In the year 2003, what is the difference between the Gross intake ratio(%) of Japan and Gross intake ratio(%) of Seychelles?
Your answer should be compact. -7.76. In the year 2004, what is the difference between the Gross intake ratio(%) of Arab World and Gross intake ratio(%) of North America?
Provide a short and direct response. -4.66. In the year 2004, what is the difference between the Gross intake ratio(%) of Arab World and Gross intake ratio(%) of Japan?
Give a very brief answer. -4.52. In the year 2004, what is the difference between the Gross intake ratio(%) of Arab World and Gross intake ratio(%) of Seychelles?
Your response must be concise. 0.55. In the year 2004, what is the difference between the Gross intake ratio(%) of North America and Gross intake ratio(%) of Japan?
Provide a succinct answer. 0.14. In the year 2004, what is the difference between the Gross intake ratio(%) of North America and Gross intake ratio(%) of Seychelles?
Your answer should be compact. 5.21. In the year 2004, what is the difference between the Gross intake ratio(%) in Japan and Gross intake ratio(%) in Seychelles?
Ensure brevity in your answer.  5.08. In the year 2005, what is the difference between the Gross intake ratio(%) of Arab World and Gross intake ratio(%) of North America?
Your answer should be very brief. -6.09. In the year 2005, what is the difference between the Gross intake ratio(%) in Arab World and Gross intake ratio(%) in Japan?
Provide a succinct answer. -1.84. In the year 2005, what is the difference between the Gross intake ratio(%) in Arab World and Gross intake ratio(%) in Seychelles?
Offer a very short reply. -6.83. In the year 2005, what is the difference between the Gross intake ratio(%) in North America and Gross intake ratio(%) in Japan?
Your answer should be compact. 4.25. In the year 2005, what is the difference between the Gross intake ratio(%) of North America and Gross intake ratio(%) of Seychelles?
Your response must be concise. -0.75. In the year 2005, what is the difference between the Gross intake ratio(%) in Japan and Gross intake ratio(%) in Seychelles?
Your answer should be compact. -5. In the year 2007, what is the difference between the Gross intake ratio(%) in Arab World and Gross intake ratio(%) in North America?
Provide a short and direct response. -2.01. In the year 2007, what is the difference between the Gross intake ratio(%) in Arab World and Gross intake ratio(%) in Japan?
Your response must be concise. 0.68. In the year 2007, what is the difference between the Gross intake ratio(%) of Arab World and Gross intake ratio(%) of Seychelles?
Offer a terse response. 0.47. In the year 2007, what is the difference between the Gross intake ratio(%) of North America and Gross intake ratio(%) of Japan?
Your answer should be compact. 2.7. In the year 2007, what is the difference between the Gross intake ratio(%) of North America and Gross intake ratio(%) of Seychelles?
Make the answer very short. 2.48. In the year 2007, what is the difference between the Gross intake ratio(%) in Japan and Gross intake ratio(%) in Seychelles?
Provide a short and direct response. -0.22. What is the ratio of the Gross intake ratio(%) in Arab World in 1999 to that in 2000?
Provide a short and direct response. 0.99. What is the ratio of the Gross intake ratio(%) in North America in 1999 to that in 2000?
Make the answer very short. 1.02. What is the ratio of the Gross intake ratio(%) of Japan in 1999 to that in 2000?
Give a very brief answer. 1. What is the ratio of the Gross intake ratio(%) of North America in 1999 to that in 2001?
Keep it short and to the point. 1.06. What is the ratio of the Gross intake ratio(%) of Seychelles in 1999 to that in 2001?
Offer a terse response. 1.06. What is the ratio of the Gross intake ratio(%) in Arab World in 1999 to that in 2002?
Make the answer very short. 0.96. What is the ratio of the Gross intake ratio(%) in North America in 1999 to that in 2002?
Make the answer very short. 1.09. What is the ratio of the Gross intake ratio(%) of Seychelles in 1999 to that in 2002?
Ensure brevity in your answer.  1.03. What is the ratio of the Gross intake ratio(%) of Arab World in 1999 to that in 2003?
Provide a short and direct response. 0.97. What is the ratio of the Gross intake ratio(%) of North America in 1999 to that in 2003?
Provide a short and direct response. 1.06. What is the ratio of the Gross intake ratio(%) of Japan in 1999 to that in 2003?
Provide a succinct answer. 1. What is the ratio of the Gross intake ratio(%) of Arab World in 1999 to that in 2004?
Give a very brief answer. 0.96. What is the ratio of the Gross intake ratio(%) in North America in 1999 to that in 2004?
Offer a very short reply. 1.06. What is the ratio of the Gross intake ratio(%) in Japan in 1999 to that in 2004?
Provide a short and direct response. 0.99. What is the ratio of the Gross intake ratio(%) of Seychelles in 1999 to that in 2004?
Your answer should be compact. 1.12. What is the ratio of the Gross intake ratio(%) of Arab World in 1999 to that in 2005?
Make the answer very short. 0.94. What is the ratio of the Gross intake ratio(%) in North America in 1999 to that in 2005?
Provide a succinct answer. 1.02. What is the ratio of the Gross intake ratio(%) of Japan in 1999 to that in 2005?
Your answer should be compact. 0.99. What is the ratio of the Gross intake ratio(%) of Seychelles in 1999 to that in 2005?
Your answer should be very brief. 1.03. What is the ratio of the Gross intake ratio(%) of Arab World in 1999 to that in 2007?
Offer a very short reply. 0.92. What is the ratio of the Gross intake ratio(%) in North America in 1999 to that in 2007?
Keep it short and to the point. 1.04. What is the ratio of the Gross intake ratio(%) of Seychelles in 1999 to that in 2007?
Keep it short and to the point. 1.08. What is the ratio of the Gross intake ratio(%) of North America in 2000 to that in 2001?
Offer a very short reply. 1.04. What is the ratio of the Gross intake ratio(%) in Japan in 2000 to that in 2001?
Your response must be concise. 1. What is the ratio of the Gross intake ratio(%) of Seychelles in 2000 to that in 2001?
Your answer should be compact. 1.05. What is the ratio of the Gross intake ratio(%) of North America in 2000 to that in 2002?
Your answer should be compact. 1.07. What is the ratio of the Gross intake ratio(%) of Seychelles in 2000 to that in 2002?
Offer a terse response. 1.03. What is the ratio of the Gross intake ratio(%) of Arab World in 2000 to that in 2003?
Give a very brief answer. 0.98. What is the ratio of the Gross intake ratio(%) of North America in 2000 to that in 2003?
Your answer should be compact. 1.04. What is the ratio of the Gross intake ratio(%) of Japan in 2000 to that in 2003?
Provide a succinct answer. 1. What is the ratio of the Gross intake ratio(%) of Seychelles in 2000 to that in 2003?
Your response must be concise. 1.01. What is the ratio of the Gross intake ratio(%) in Arab World in 2000 to that in 2004?
Give a very brief answer. 0.98. What is the ratio of the Gross intake ratio(%) in North America in 2000 to that in 2004?
Provide a short and direct response. 1.03. What is the ratio of the Gross intake ratio(%) of Japan in 2000 to that in 2004?
Your answer should be compact. 0.99. What is the ratio of the Gross intake ratio(%) in Seychelles in 2000 to that in 2004?
Provide a short and direct response. 1.12. What is the ratio of the Gross intake ratio(%) of Arab World in 2000 to that in 2005?
Make the answer very short. 0.96. What is the ratio of the Gross intake ratio(%) of North America in 2000 to that in 2005?
Offer a terse response. 1. What is the ratio of the Gross intake ratio(%) in Seychelles in 2000 to that in 2005?
Give a very brief answer. 1.03. What is the ratio of the Gross intake ratio(%) of Arab World in 2000 to that in 2007?
Ensure brevity in your answer.  0.94. What is the ratio of the Gross intake ratio(%) in Seychelles in 2000 to that in 2007?
Offer a terse response. 1.08. What is the ratio of the Gross intake ratio(%) in Arab World in 2001 to that in 2002?
Provide a succinct answer. 0.97. What is the ratio of the Gross intake ratio(%) in North America in 2001 to that in 2002?
Your response must be concise. 1.03. What is the ratio of the Gross intake ratio(%) of Japan in 2001 to that in 2002?
Offer a terse response. 0.96. What is the ratio of the Gross intake ratio(%) of Seychelles in 2001 to that in 2002?
Provide a short and direct response. 0.98. What is the ratio of the Gross intake ratio(%) of Arab World in 2001 to that in 2003?
Your response must be concise. 0.98. What is the ratio of the Gross intake ratio(%) of Seychelles in 2001 to that in 2003?
Offer a very short reply. 0.96. What is the ratio of the Gross intake ratio(%) of Arab World in 2001 to that in 2004?
Offer a very short reply. 0.97. What is the ratio of the Gross intake ratio(%) in North America in 2001 to that in 2004?
Offer a very short reply. 0.99. What is the ratio of the Gross intake ratio(%) in Japan in 2001 to that in 2004?
Give a very brief answer. 0.98. What is the ratio of the Gross intake ratio(%) in Seychelles in 2001 to that in 2004?
Keep it short and to the point. 1.07. What is the ratio of the Gross intake ratio(%) of Arab World in 2001 to that in 2005?
Offer a very short reply. 0.96. What is the ratio of the Gross intake ratio(%) in North America in 2001 to that in 2005?
Your answer should be very brief. 0.96. What is the ratio of the Gross intake ratio(%) of Seychelles in 2001 to that in 2005?
Keep it short and to the point. 0.97. What is the ratio of the Gross intake ratio(%) in Arab World in 2001 to that in 2007?
Give a very brief answer. 0.93. What is the ratio of the Gross intake ratio(%) in North America in 2001 to that in 2007?
Make the answer very short. 0.98. What is the ratio of the Gross intake ratio(%) in Japan in 2001 to that in 2007?
Provide a succinct answer. 0.99. What is the ratio of the Gross intake ratio(%) in Seychelles in 2001 to that in 2007?
Keep it short and to the point. 1.02. What is the ratio of the Gross intake ratio(%) in Arab World in 2002 to that in 2003?
Your answer should be compact. 1.01. What is the ratio of the Gross intake ratio(%) in North America in 2002 to that in 2003?
Ensure brevity in your answer.  0.97. What is the ratio of the Gross intake ratio(%) of Japan in 2002 to that in 2003?
Your response must be concise. 1.04. What is the ratio of the Gross intake ratio(%) of Seychelles in 2002 to that in 2003?
Keep it short and to the point. 0.98. What is the ratio of the Gross intake ratio(%) of Arab World in 2002 to that in 2004?
Offer a terse response. 1. What is the ratio of the Gross intake ratio(%) in North America in 2002 to that in 2004?
Keep it short and to the point. 0.97. What is the ratio of the Gross intake ratio(%) in Japan in 2002 to that in 2004?
Provide a succinct answer. 1.02. What is the ratio of the Gross intake ratio(%) in Seychelles in 2002 to that in 2004?
Ensure brevity in your answer.  1.09. What is the ratio of the Gross intake ratio(%) of Arab World in 2002 to that in 2005?
Provide a short and direct response. 0.99. What is the ratio of the Gross intake ratio(%) in North America in 2002 to that in 2005?
Ensure brevity in your answer.  0.94. What is the ratio of the Gross intake ratio(%) in Japan in 2002 to that in 2005?
Your response must be concise. 1.03. What is the ratio of the Gross intake ratio(%) of Seychelles in 2002 to that in 2005?
Your answer should be very brief. 0.99. What is the ratio of the Gross intake ratio(%) of Arab World in 2002 to that in 2007?
Provide a succinct answer. 0.96. What is the ratio of the Gross intake ratio(%) of North America in 2002 to that in 2007?
Your answer should be compact. 0.95. What is the ratio of the Gross intake ratio(%) in Japan in 2002 to that in 2007?
Ensure brevity in your answer.  1.03. What is the ratio of the Gross intake ratio(%) of Seychelles in 2002 to that in 2007?
Provide a succinct answer. 1.04. What is the ratio of the Gross intake ratio(%) in Japan in 2003 to that in 2004?
Give a very brief answer. 0.98. What is the ratio of the Gross intake ratio(%) of Seychelles in 2003 to that in 2004?
Offer a very short reply. 1.11. What is the ratio of the Gross intake ratio(%) of Arab World in 2003 to that in 2005?
Your response must be concise. 0.98. What is the ratio of the Gross intake ratio(%) of North America in 2003 to that in 2005?
Ensure brevity in your answer.  0.96. What is the ratio of the Gross intake ratio(%) of Japan in 2003 to that in 2005?
Provide a short and direct response. 0.99. What is the ratio of the Gross intake ratio(%) in Seychelles in 2003 to that in 2005?
Your answer should be very brief. 1.02. What is the ratio of the Gross intake ratio(%) of Arab World in 2003 to that in 2007?
Provide a short and direct response. 0.96. What is the ratio of the Gross intake ratio(%) in North America in 2003 to that in 2007?
Offer a very short reply. 0.98. What is the ratio of the Gross intake ratio(%) of Japan in 2003 to that in 2007?
Keep it short and to the point. 0.99. What is the ratio of the Gross intake ratio(%) in Seychelles in 2003 to that in 2007?
Your answer should be compact. 1.07. What is the ratio of the Gross intake ratio(%) of Arab World in 2004 to that in 2005?
Your answer should be very brief. 0.98. What is the ratio of the Gross intake ratio(%) of North America in 2004 to that in 2005?
Offer a terse response. 0.97. What is the ratio of the Gross intake ratio(%) of Japan in 2004 to that in 2005?
Provide a succinct answer. 1.01. What is the ratio of the Gross intake ratio(%) in Seychelles in 2004 to that in 2005?
Provide a short and direct response. 0.91. What is the ratio of the Gross intake ratio(%) in Arab World in 2004 to that in 2007?
Provide a succinct answer. 0.96. What is the ratio of the Gross intake ratio(%) in North America in 2004 to that in 2007?
Offer a very short reply. 0.99. What is the ratio of the Gross intake ratio(%) of Japan in 2004 to that in 2007?
Keep it short and to the point. 1.01. What is the ratio of the Gross intake ratio(%) in Seychelles in 2004 to that in 2007?
Make the answer very short. 0.96. What is the ratio of the Gross intake ratio(%) of Arab World in 2005 to that in 2007?
Ensure brevity in your answer.  0.98. What is the ratio of the Gross intake ratio(%) of North America in 2005 to that in 2007?
Your answer should be very brief. 1.02. What is the ratio of the Gross intake ratio(%) in Japan in 2005 to that in 2007?
Ensure brevity in your answer.  1. What is the ratio of the Gross intake ratio(%) in Seychelles in 2005 to that in 2007?
Ensure brevity in your answer.  1.05. What is the difference between the highest and the second highest Gross intake ratio(%) in Arab World?
Your answer should be compact. 2.47. What is the difference between the highest and the second highest Gross intake ratio(%) in North America?
Offer a very short reply. 2.22. What is the difference between the highest and the second highest Gross intake ratio(%) in Japan?
Ensure brevity in your answer.  2.39. What is the difference between the highest and the second highest Gross intake ratio(%) in Seychelles?
Ensure brevity in your answer.  0.05. What is the difference between the highest and the lowest Gross intake ratio(%) in Arab World?
Your answer should be very brief. 7.97. What is the difference between the highest and the lowest Gross intake ratio(%) of North America?
Offer a terse response. 9.1. What is the difference between the highest and the lowest Gross intake ratio(%) of Japan?
Your answer should be compact. 4.17. What is the difference between the highest and the lowest Gross intake ratio(%) of Seychelles?
Provide a short and direct response. 12.14. 